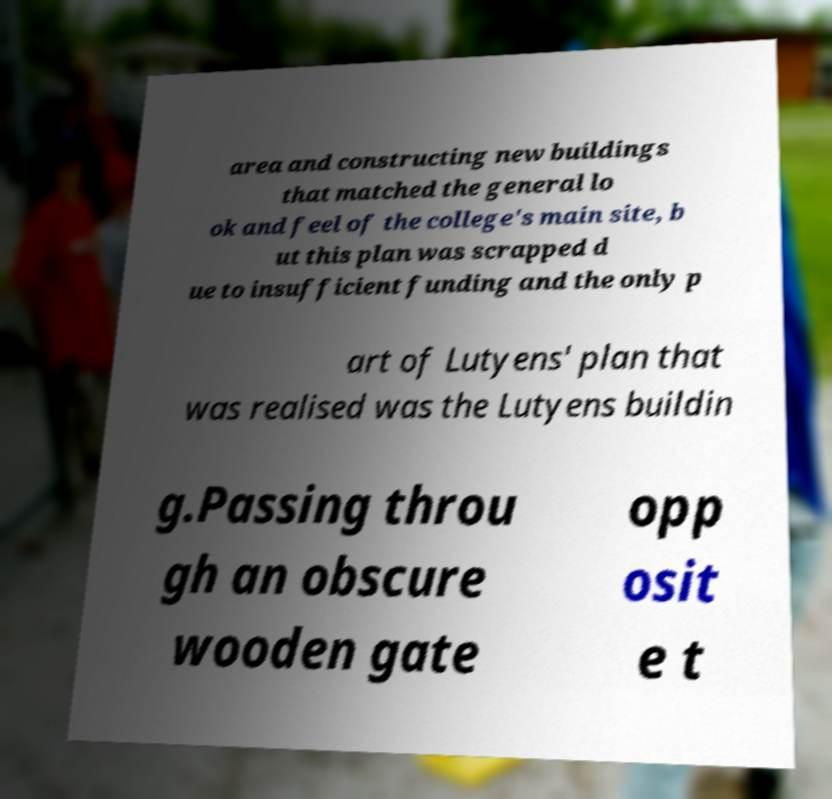Can you read and provide the text displayed in the image?This photo seems to have some interesting text. Can you extract and type it out for me? area and constructing new buildings that matched the general lo ok and feel of the college's main site, b ut this plan was scrapped d ue to insufficient funding and the only p art of Lutyens' plan that was realised was the Lutyens buildin g.Passing throu gh an obscure wooden gate opp osit e t 